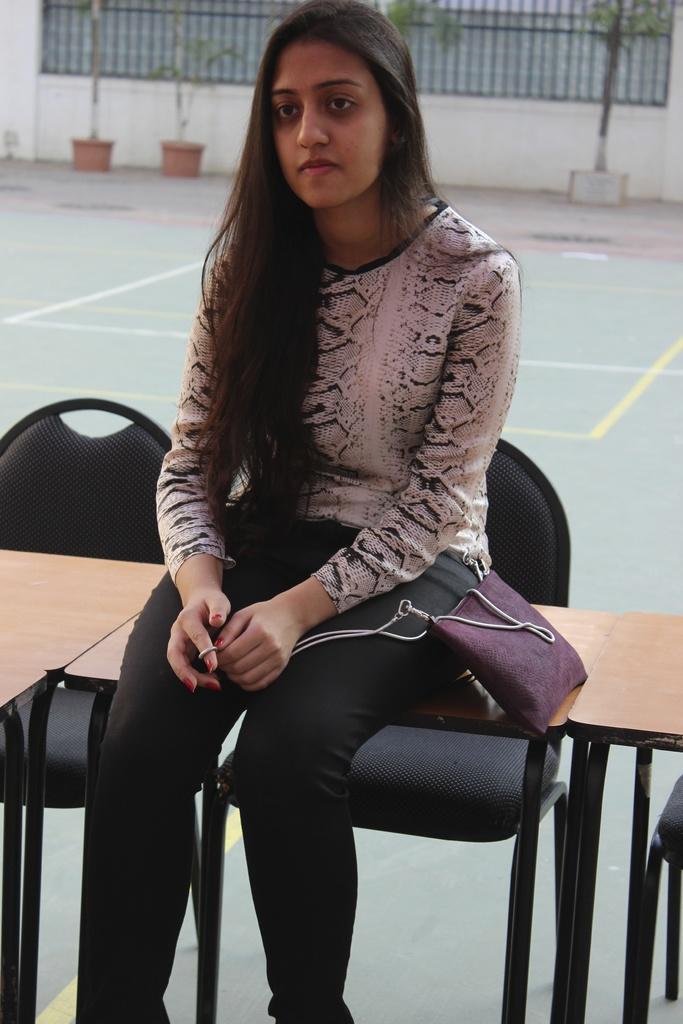Please provide a concise description of this image. The girl wearing white shirt and black pant and carrying a violet purse with her is sitting on a table and there are also black chair's behind her and there are also trees in the background. 